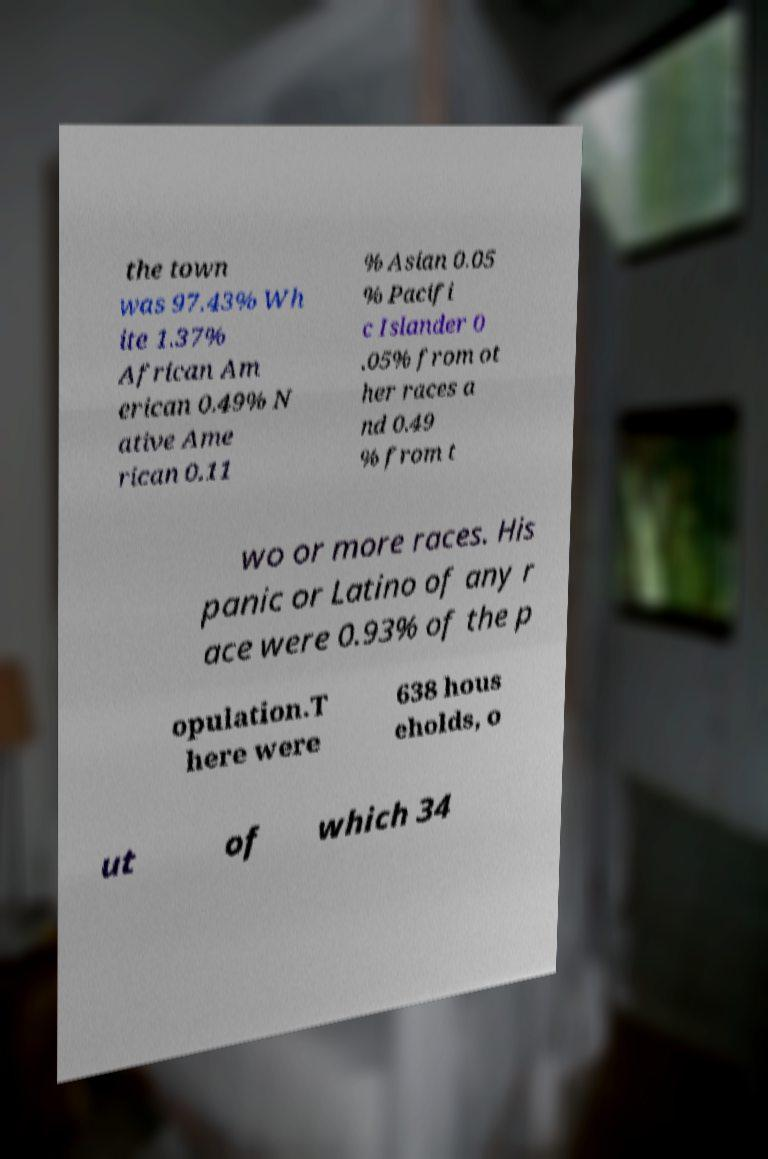What messages or text are displayed in this image? I need them in a readable, typed format. the town was 97.43% Wh ite 1.37% African Am erican 0.49% N ative Ame rican 0.11 % Asian 0.05 % Pacifi c Islander 0 .05% from ot her races a nd 0.49 % from t wo or more races. His panic or Latino of any r ace were 0.93% of the p opulation.T here were 638 hous eholds, o ut of which 34 